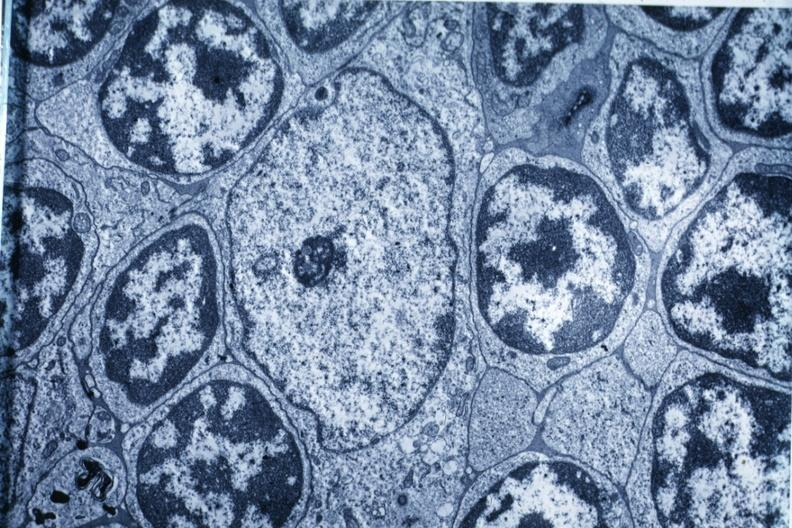does esophagus show electron micrograph?
Answer the question using a single word or phrase. No 